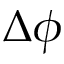<formula> <loc_0><loc_0><loc_500><loc_500>\Delta \phi</formula> 